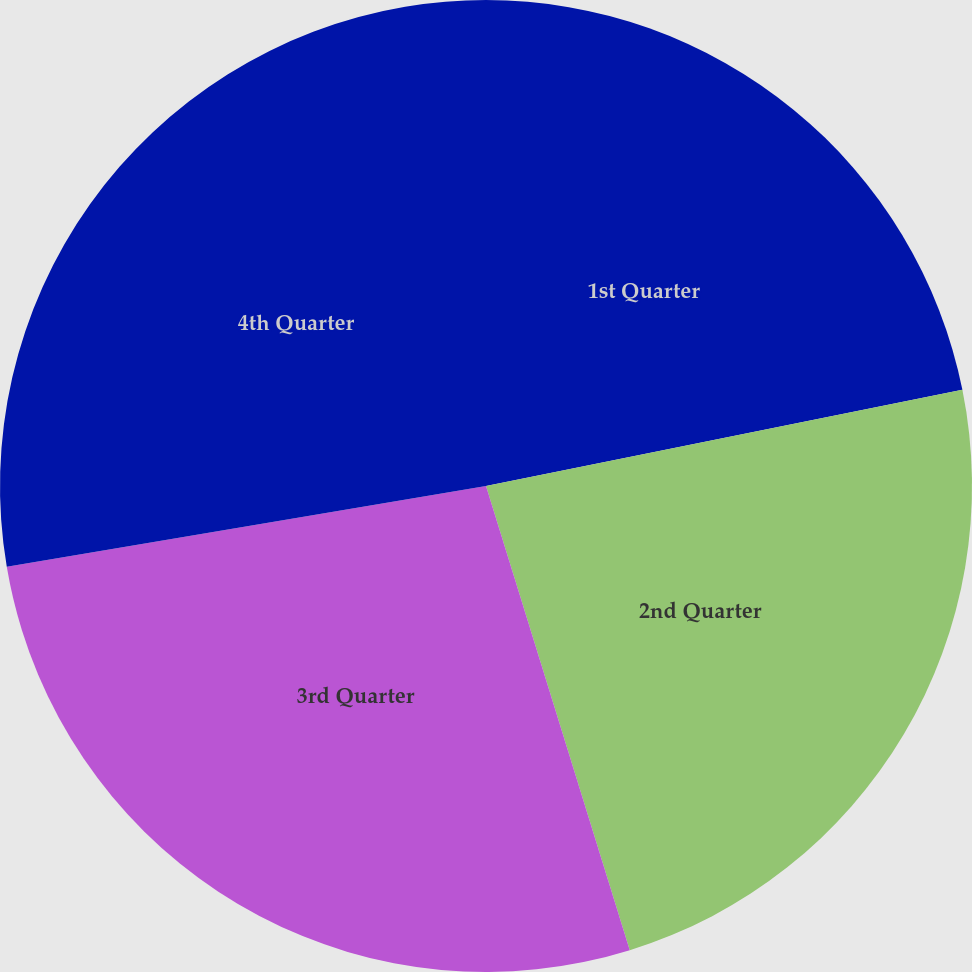Convert chart. <chart><loc_0><loc_0><loc_500><loc_500><pie_chart><fcel>1st Quarter<fcel>2nd Quarter<fcel>3rd Quarter<fcel>4th Quarter<nl><fcel>21.83%<fcel>23.39%<fcel>27.12%<fcel>27.66%<nl></chart> 